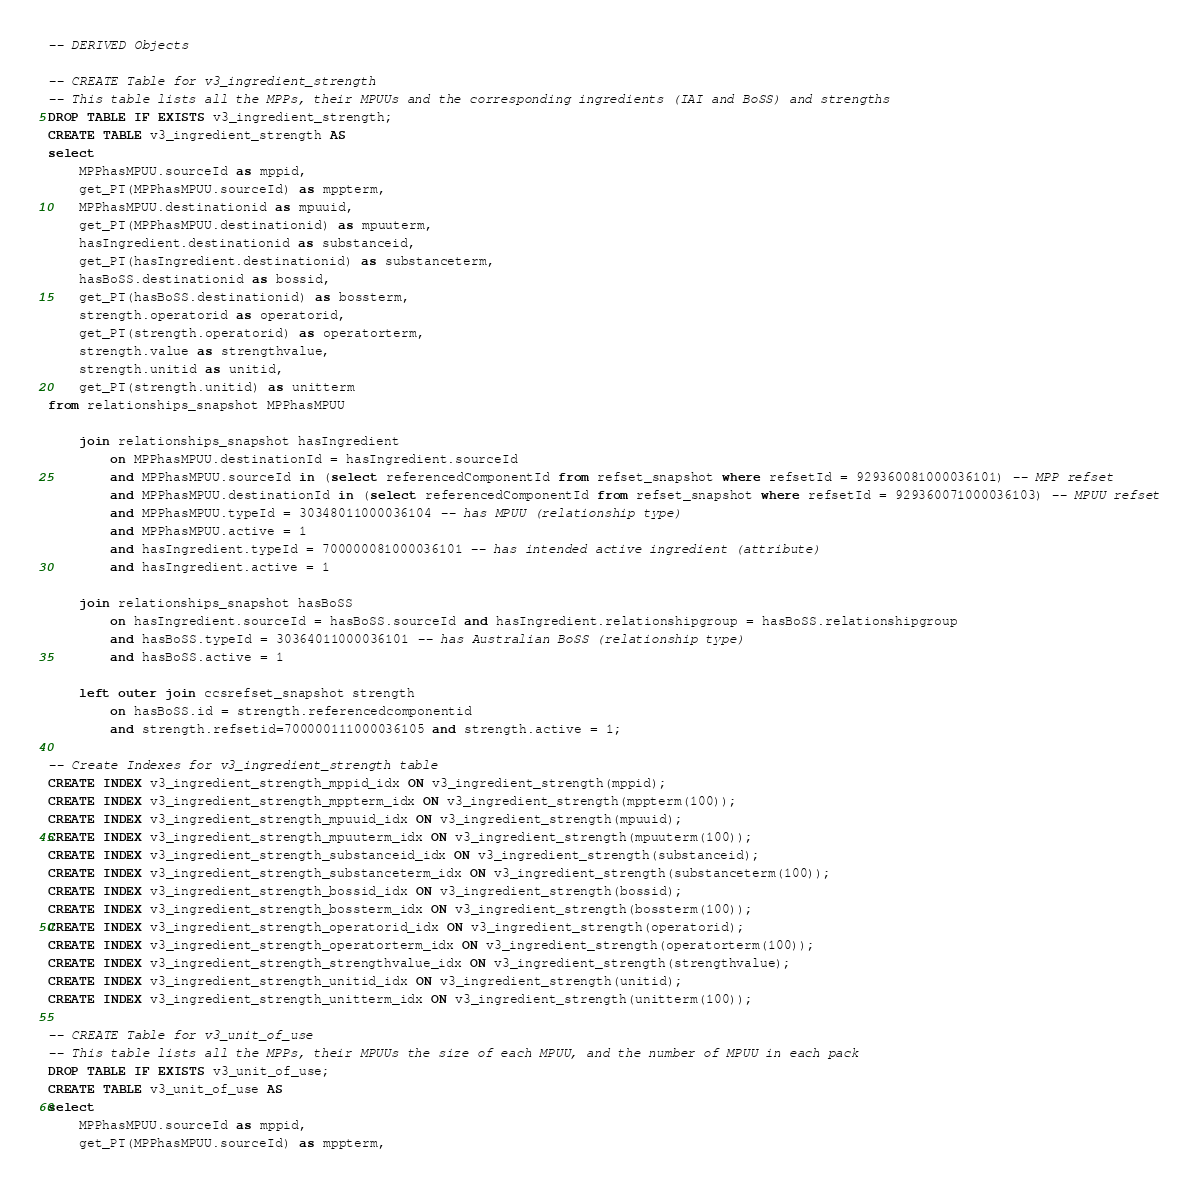Convert code to text. <code><loc_0><loc_0><loc_500><loc_500><_SQL_>-- DERIVED Objects

-- CREATE Table for v3_ingredient_strength
-- This table lists all the MPPs, their MPUUs and the corresponding ingredients (IAI and BoSS) and strengths
DROP TABLE IF EXISTS v3_ingredient_strength;
CREATE TABLE v3_ingredient_strength AS
select 
    MPPhasMPUU.sourceId as mppid,
    get_PT(MPPhasMPUU.sourceId) as mppterm,
    MPPhasMPUU.destinationid as mpuuid,
    get_PT(MPPhasMPUU.destinationid) as mpuuterm,
    hasIngredient.destinationid as substanceid,
    get_PT(hasIngredient.destinationid) as substanceterm,
    hasBoSS.destinationid as bossid,
    get_PT(hasBoSS.destinationid) as bossterm,
    strength.operatorid as operatorid,
    get_PT(strength.operatorid) as operatorterm,
    strength.value as strengthvalue,
    strength.unitid as unitid,
    get_PT(strength.unitid) as unitterm
from relationships_snapshot MPPhasMPUU

    join relationships_snapshot hasIngredient
        on MPPhasMPUU.destinationId = hasIngredient.sourceId
        and MPPhasMPUU.sourceId in (select referencedComponentId from refset_snapshot where refsetId = 929360081000036101) -- MPP refset
        and MPPhasMPUU.destinationId in (select referencedComponentId from refset_snapshot where refsetId = 929360071000036103) -- MPUU refset
        and MPPhasMPUU.typeId = 30348011000036104 -- has MPUU (relationship type)
        and MPPhasMPUU.active = 1
        and hasIngredient.typeId = 700000081000036101 -- has intended active ingredient (attribute)
        and hasIngredient.active = 1

    join relationships_snapshot hasBoSS
        on hasIngredient.sourceId = hasBoSS.sourceId and hasIngredient.relationshipgroup = hasBoSS.relationshipgroup
        and hasBoSS.typeId = 30364011000036101 -- has Australian BoSS (relationship type)
        and hasBoSS.active = 1

    left outer join ccsrefset_snapshot strength
        on hasBoSS.id = strength.referencedcomponentid
        and strength.refsetid=700000111000036105 and strength.active = 1;

-- Create Indexes for v3_ingredient_strength table
CREATE INDEX v3_ingredient_strength_mppid_idx ON v3_ingredient_strength(mppid);
CREATE INDEX v3_ingredient_strength_mppterm_idx ON v3_ingredient_strength(mppterm(100));
CREATE INDEX v3_ingredient_strength_mpuuid_idx ON v3_ingredient_strength(mpuuid);
CREATE INDEX v3_ingredient_strength_mpuuterm_idx ON v3_ingredient_strength(mpuuterm(100));
CREATE INDEX v3_ingredient_strength_substanceid_idx ON v3_ingredient_strength(substanceid);
CREATE INDEX v3_ingredient_strength_substanceterm_idx ON v3_ingredient_strength(substanceterm(100));
CREATE INDEX v3_ingredient_strength_bossid_idx ON v3_ingredient_strength(bossid);
CREATE INDEX v3_ingredient_strength_bossterm_idx ON v3_ingredient_strength(bossterm(100));
CREATE INDEX v3_ingredient_strength_operatorid_idx ON v3_ingredient_strength(operatorid);
CREATE INDEX v3_ingredient_strength_operatorterm_idx ON v3_ingredient_strength(operatorterm(100));
CREATE INDEX v3_ingredient_strength_strengthvalue_idx ON v3_ingredient_strength(strengthvalue);
CREATE INDEX v3_ingredient_strength_unitid_idx ON v3_ingredient_strength(unitid);
CREATE INDEX v3_ingredient_strength_unitterm_idx ON v3_ingredient_strength(unitterm(100));

-- CREATE Table for v3_unit_of_use
-- This table lists all the MPPs, their MPUUs the size of each MPUU, and the number of MPUU in each pack
DROP TABLE IF EXISTS v3_unit_of_use;
CREATE TABLE v3_unit_of_use AS
select 
    MPPhasMPUU.sourceId as mppid,
    get_PT(MPPhasMPUU.sourceId) as mppterm,</code> 